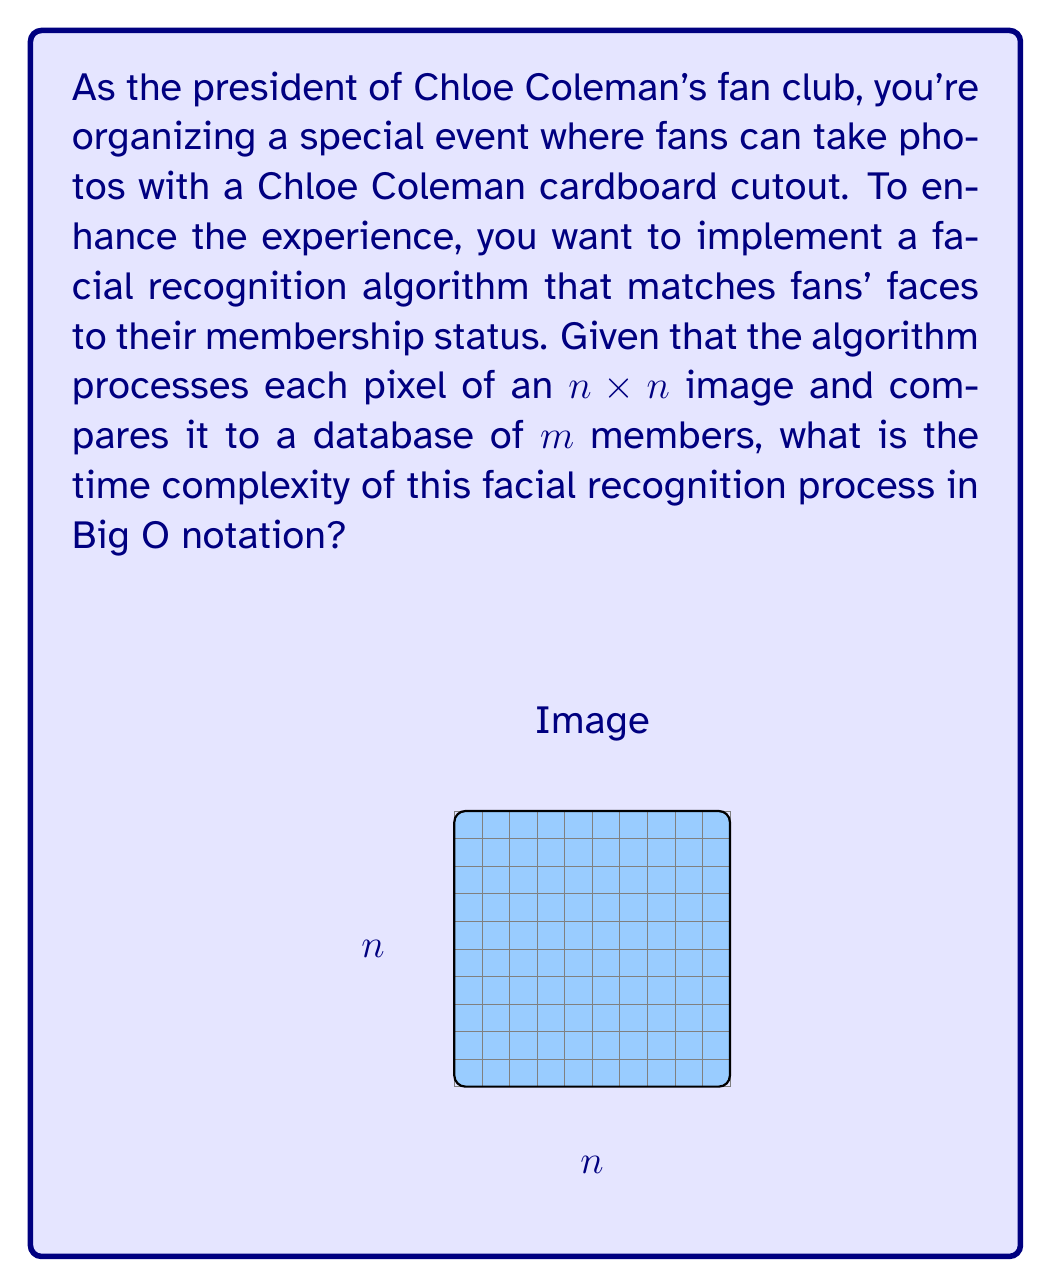What is the answer to this math problem? To determine the time complexity of this facial recognition algorithm, let's break down the process:

1. Image processing:
   - The algorithm processes each pixel of an $n \times n$ image.
   - Total number of pixels = $n^2$
   - Time complexity for image processing: $O(n^2)$

2. Database comparison:
   - Each processed image is compared to $m$ members in the database.
   - For each member comparison, we assume a constant time operation.
   - Time complexity for database comparison: $O(m)$

3. Combined process:
   - For each pixel, we perform the database comparison.
   - Total operations: $n^2 \times m$
   - Time complexity: $O(n^2 \times m)$

Therefore, the overall time complexity of the facial recognition process is $O(n^2m)$, where $n$ is the dimension of the square image and $m$ is the number of members in the database.

This complexity suggests that the algorithm's running time grows quadratically with the image size and linearly with the number of database entries, which is typical for basic facial recognition algorithms that perform pixel-by-pixel comparisons.
Answer: $O(n^2m)$ 